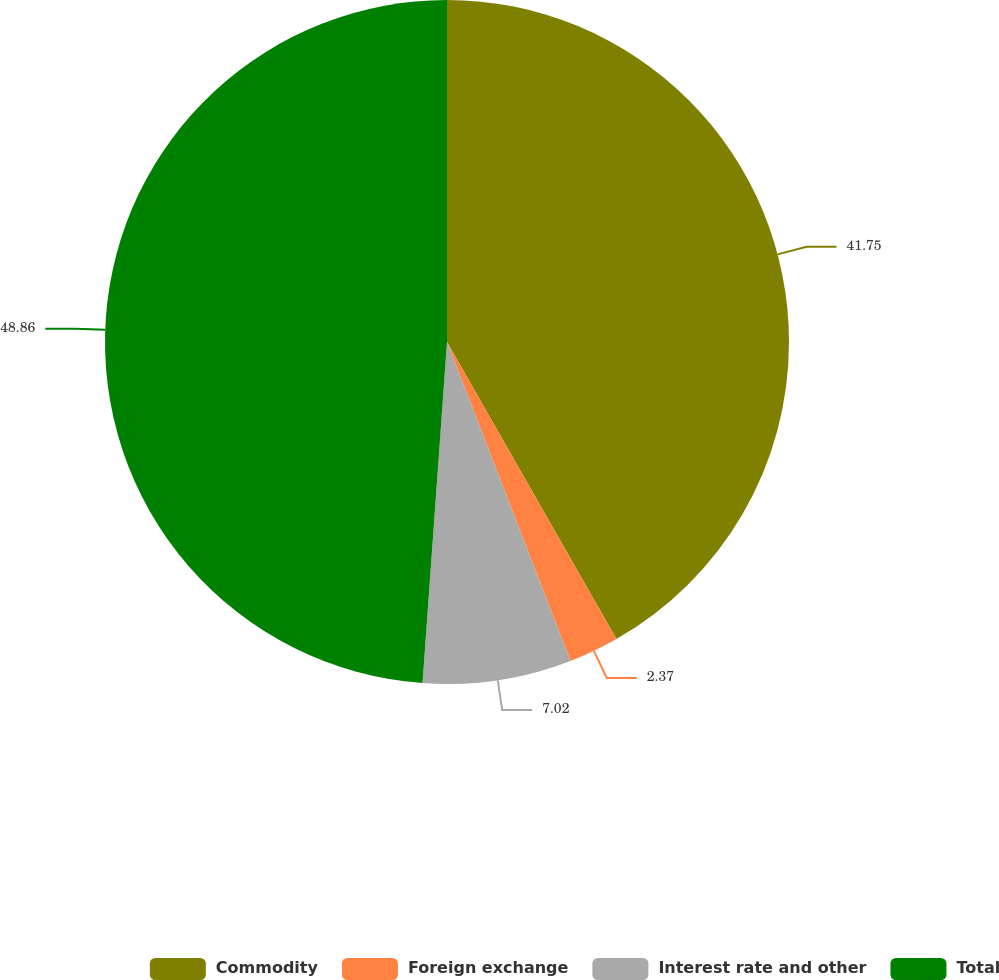Convert chart to OTSL. <chart><loc_0><loc_0><loc_500><loc_500><pie_chart><fcel>Commodity<fcel>Foreign exchange<fcel>Interest rate and other<fcel>Total<nl><fcel>41.75%<fcel>2.37%<fcel>7.02%<fcel>48.86%<nl></chart> 